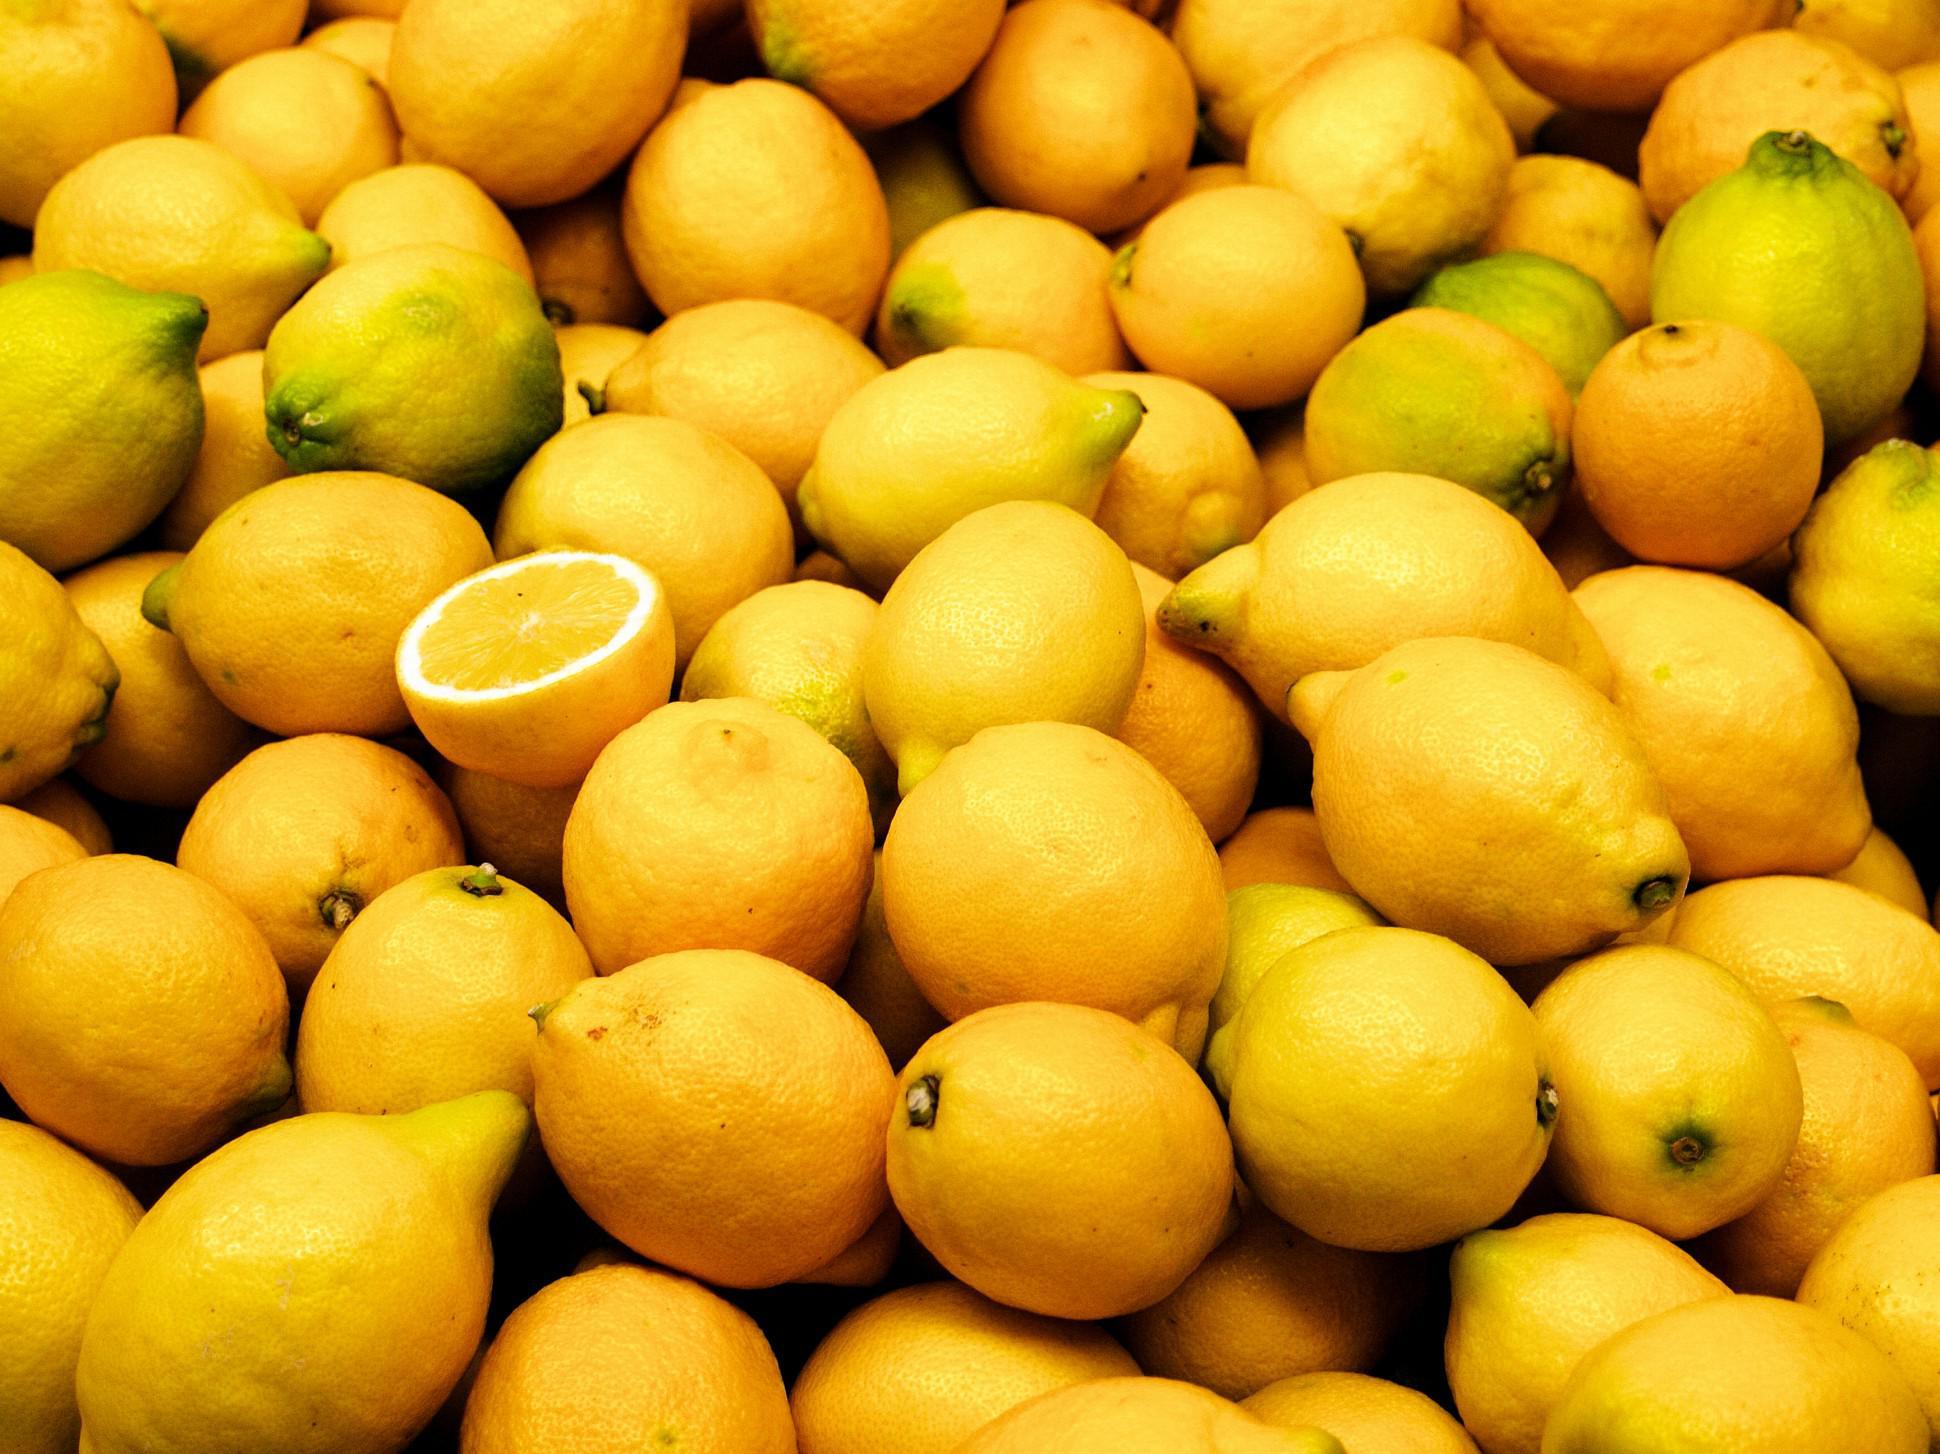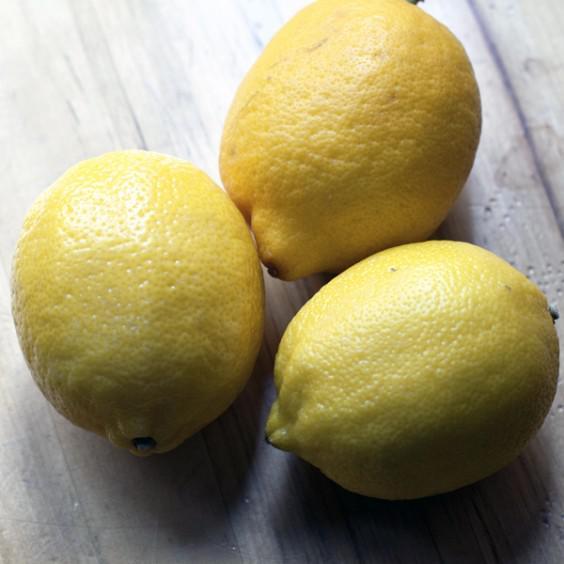The first image is the image on the left, the second image is the image on the right. Analyze the images presented: Is the assertion "There are only whole uncut lemons in the left image." valid? Answer yes or no. No. The first image is the image on the left, the second image is the image on the right. Analyze the images presented: Is the assertion "The combined images include at least one cut lemon half and multiple whole lemons, but no lemons are in a container." valid? Answer yes or no. Yes. 